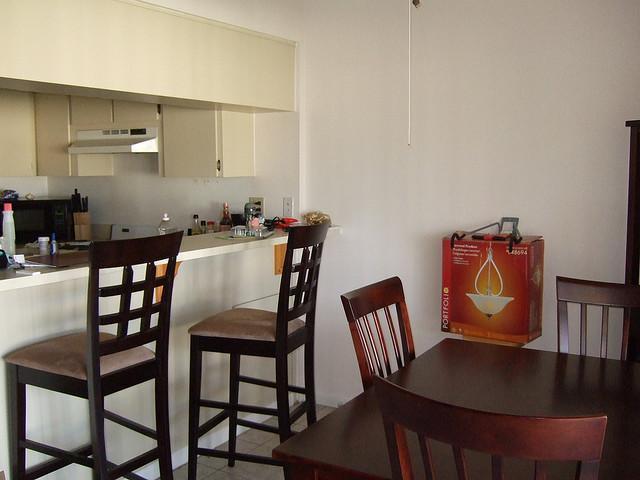How many sets of matching chairs are in the photo?
Give a very brief answer. 2. How many chairs can be seen?
Give a very brief answer. 5. 